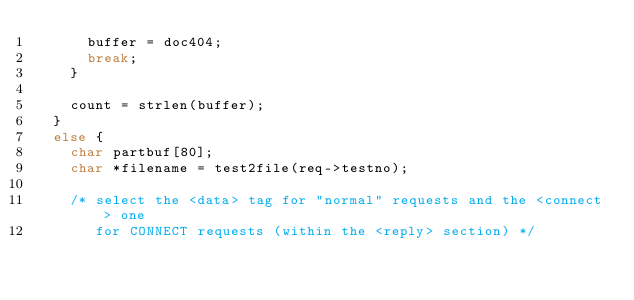Convert code to text. <code><loc_0><loc_0><loc_500><loc_500><_C_>      buffer = doc404;
      break;
    }

    count = strlen(buffer);
  }
  else {
    char partbuf[80];
    char *filename = test2file(req->testno);

    /* select the <data> tag for "normal" requests and the <connect> one
       for CONNECT requests (within the <reply> section) */</code> 